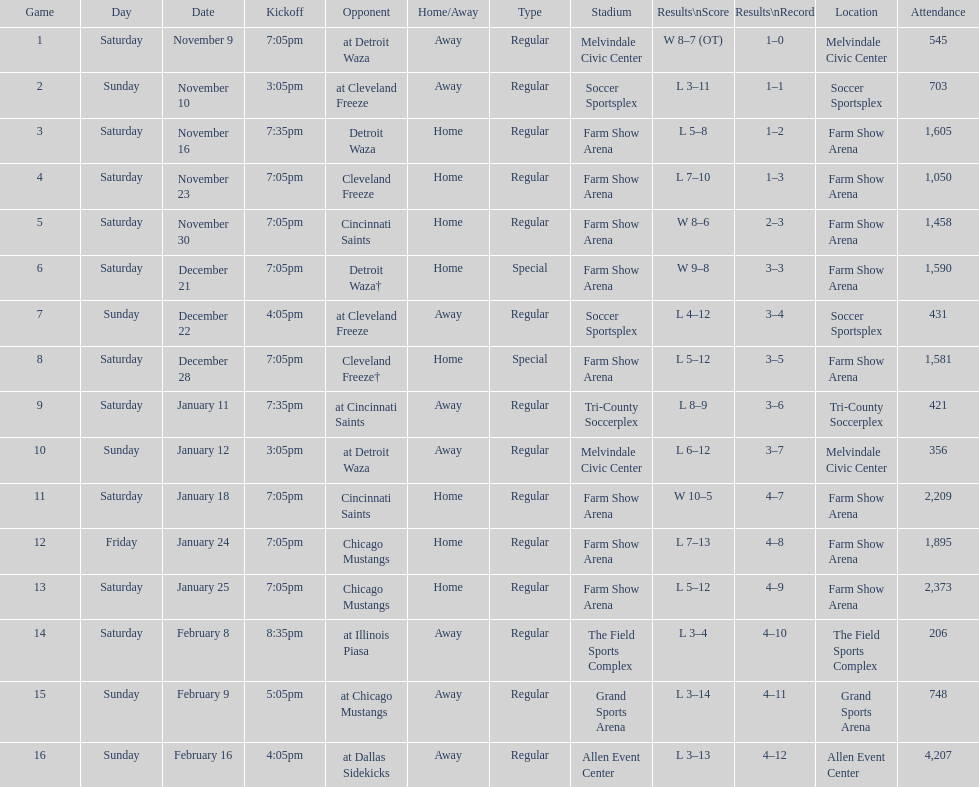How long was the teams longest losing streak? 5 games. 